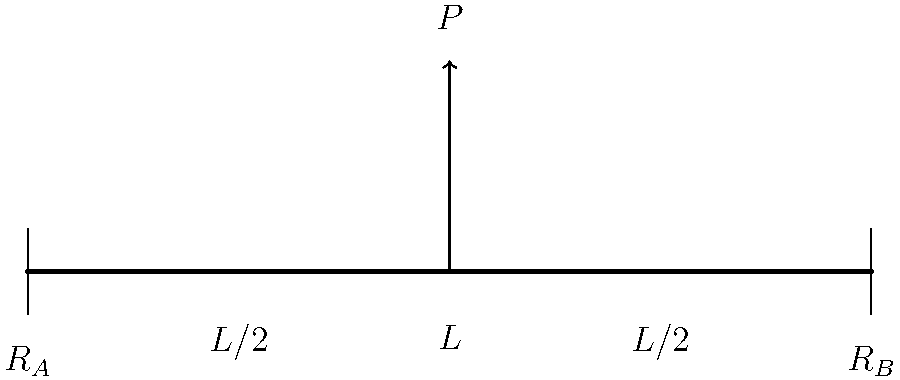As a full-stack developer familiar with API documentation, consider a simply supported beam of length $L$ with a point load $P$ applied at its midpoint. Using the principles of structural mechanics, determine the maximum bending moment in the beam. Express your answer in terms of $P$ and $L$. To solve this problem, we'll follow these steps:

1. Determine the reactions at the supports:
   Since the load is at the midpoint, the reactions are equal:
   $$R_A = R_B = \frac{P}{2}$$

2. Calculate the bending moment at any point $x$ along the beam:
   For $0 \leq x \leq L/2$:
   $$M(x) = R_A \cdot x = \frac{P}{2} \cdot x$$

   For $L/2 \leq x \leq L$:
   $$M(x) = R_A \cdot x - P \cdot (x - L/2) = \frac{P}{2} \cdot x - P \cdot (x - L/2)$$

3. Find the maximum bending moment:
   The maximum bending moment occurs at the point of load application $(x = L/2)$:
   $$M_{max} = \frac{P}{2} \cdot \frac{L}{2} = \frac{PL}{4}$$

Therefore, the maximum bending moment in the beam is $\frac{PL}{4}$.
Answer: $\frac{PL}{4}$ 